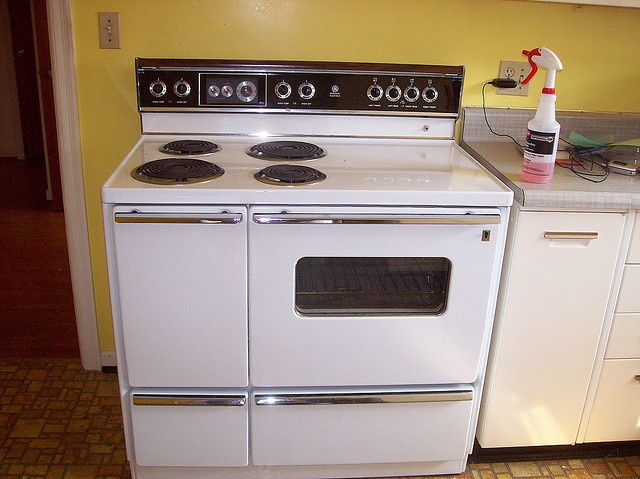Describe the objects in this image and their specific colors. I can see oven in black and lightgray tones, bottle in black, lightgray, pink, and darkgray tones, and cell phone in black and gray tones in this image. 